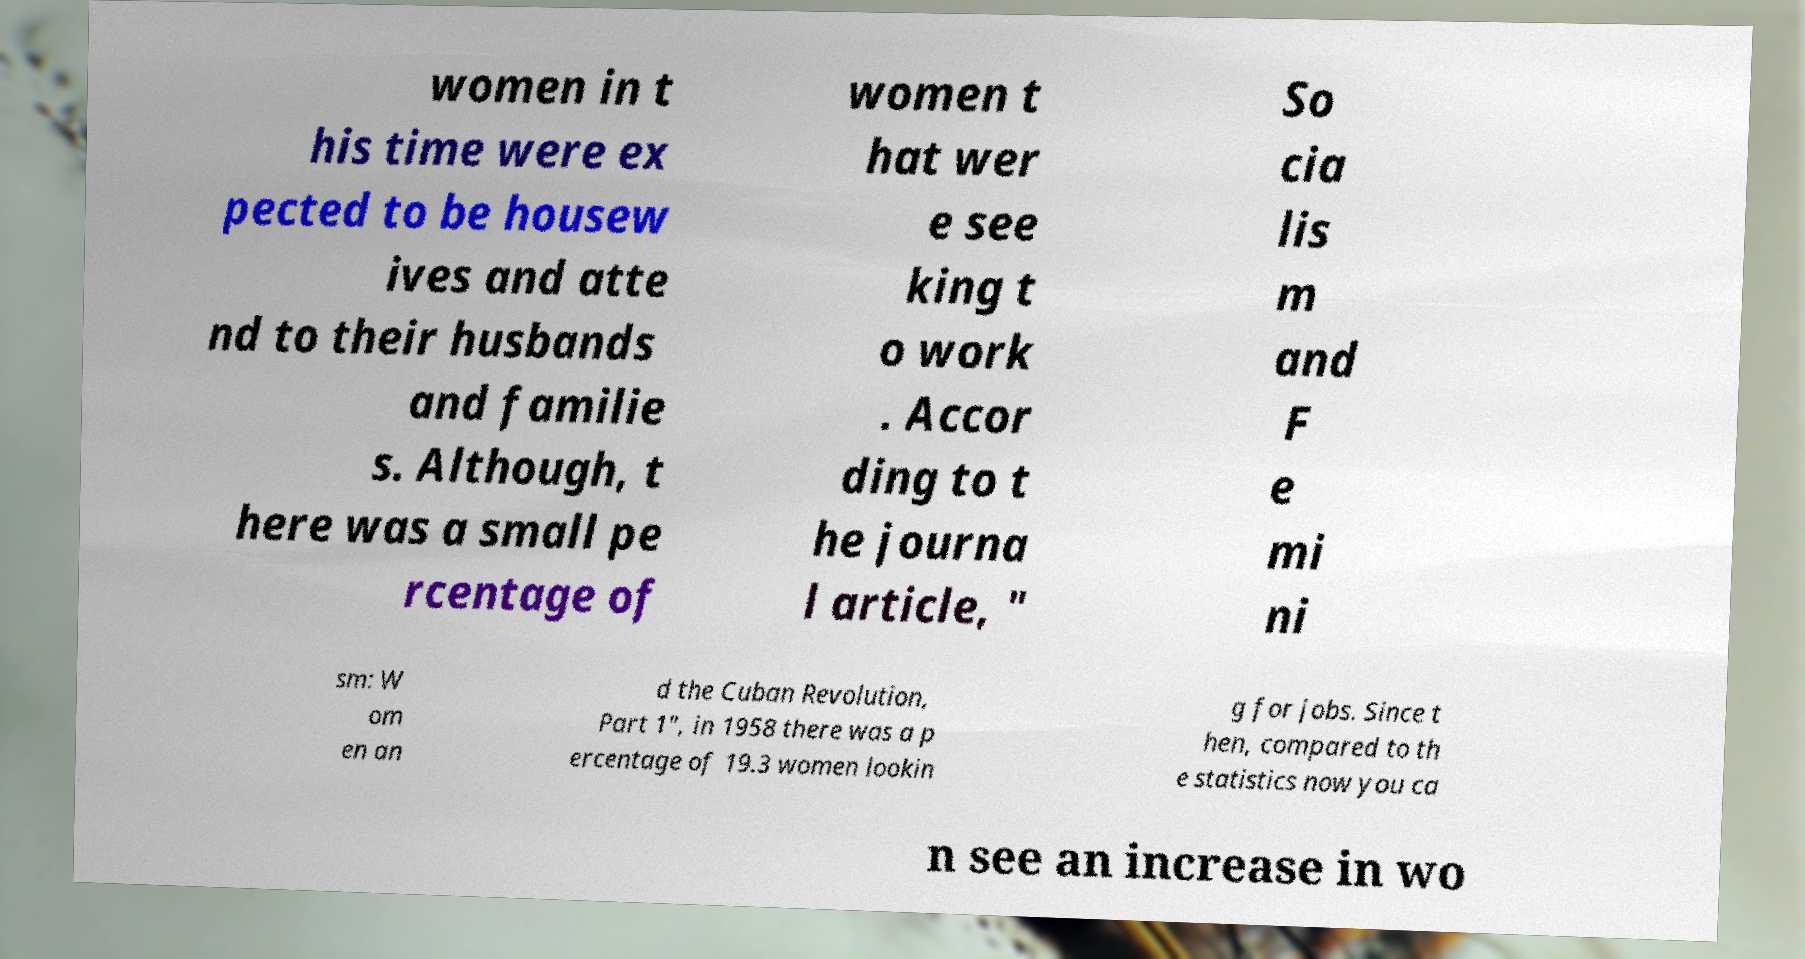There's text embedded in this image that I need extracted. Can you transcribe it verbatim? women in t his time were ex pected to be housew ives and atte nd to their husbands and familie s. Although, t here was a small pe rcentage of women t hat wer e see king t o work . Accor ding to t he journa l article, " So cia lis m and F e mi ni sm: W om en an d the Cuban Revolution, Part 1", in 1958 there was a p ercentage of 19.3 women lookin g for jobs. Since t hen, compared to th e statistics now you ca n see an increase in wo 